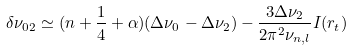Convert formula to latex. <formula><loc_0><loc_0><loc_500><loc_500>\delta \nu _ { 0 2 } \simeq ( n + \frac { 1 } { 4 } + \alpha ) ( \Delta \nu _ { 0 } - \Delta \nu _ { 2 } ) - \frac { 3 \Delta \nu _ { 2 } } { 2 \pi ^ { 2 } \nu _ { n , l } } I ( r _ { t } )</formula> 